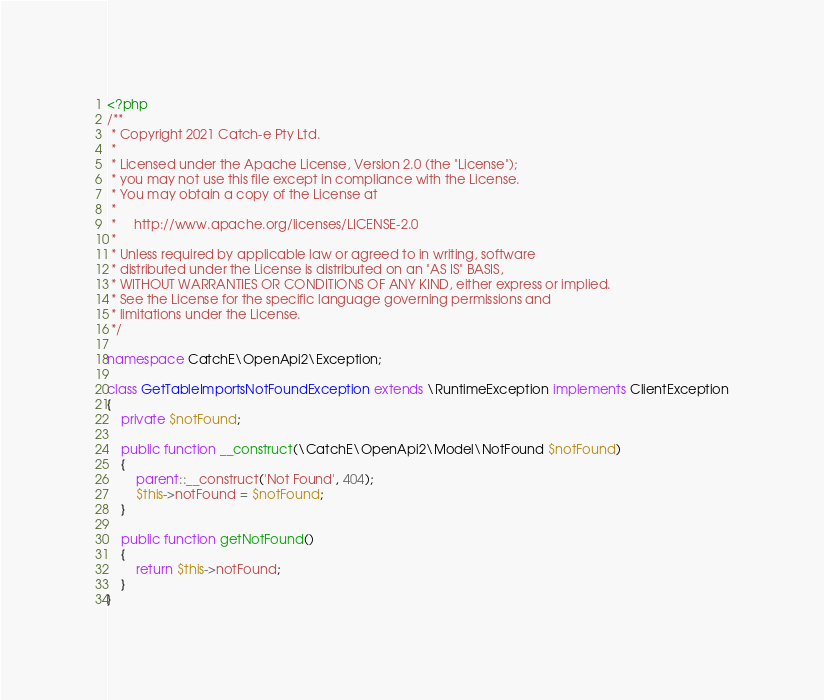Convert code to text. <code><loc_0><loc_0><loc_500><loc_500><_PHP_><?php
/**
 * Copyright 2021 Catch-e Pty Ltd.
 *
 * Licensed under the Apache License, Version 2.0 (the "License");
 * you may not use this file except in compliance with the License.
 * You may obtain a copy of the License at
 *
 *     http://www.apache.org/licenses/LICENSE-2.0
 *
 * Unless required by applicable law or agreed to in writing, software
 * distributed under the License is distributed on an "AS IS" BASIS,
 * WITHOUT WARRANTIES OR CONDITIONS OF ANY KIND, either express or implied.
 * See the License for the specific language governing permissions and
 * limitations under the License.
 */

namespace CatchE\OpenApi2\Exception;

class GetTableImportsNotFoundException extends \RuntimeException implements ClientException
{
	private $notFound;

	public function __construct(\CatchE\OpenApi2\Model\NotFound $notFound)
	{
		parent::__construct('Not Found', 404);
		$this->notFound = $notFound;
	}

	public function getNotFound()
	{
		return $this->notFound;
	}
}
</code> 